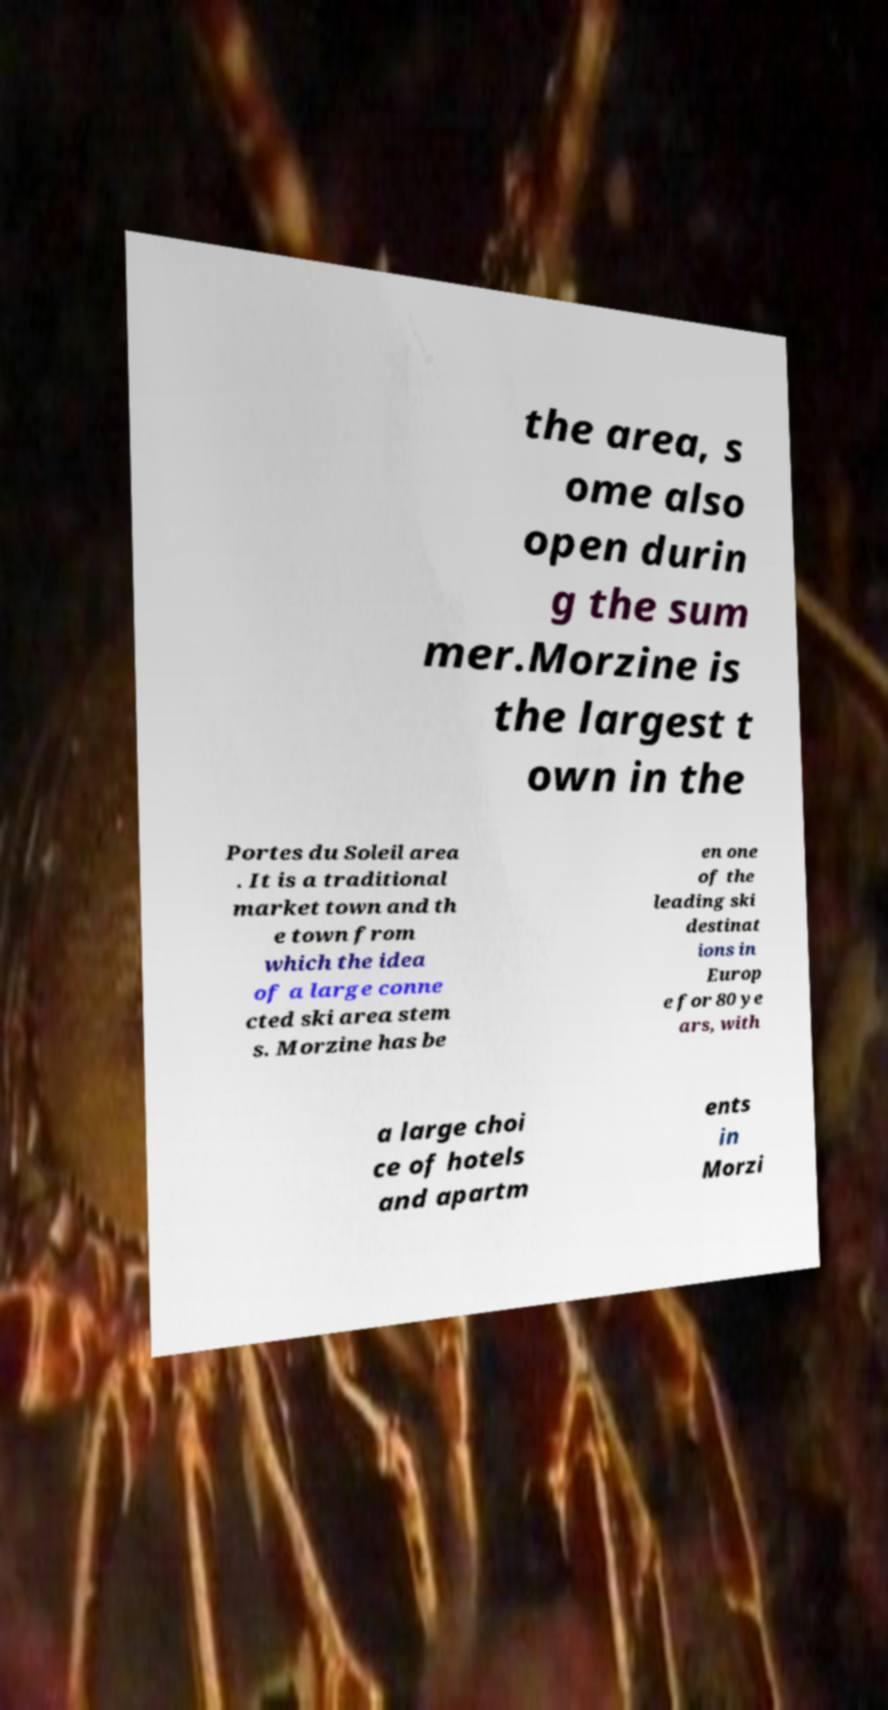Can you read and provide the text displayed in the image?This photo seems to have some interesting text. Can you extract and type it out for me? the area, s ome also open durin g the sum mer.Morzine is the largest t own in the Portes du Soleil area . It is a traditional market town and th e town from which the idea of a large conne cted ski area stem s. Morzine has be en one of the leading ski destinat ions in Europ e for 80 ye ars, with a large choi ce of hotels and apartm ents in Morzi 